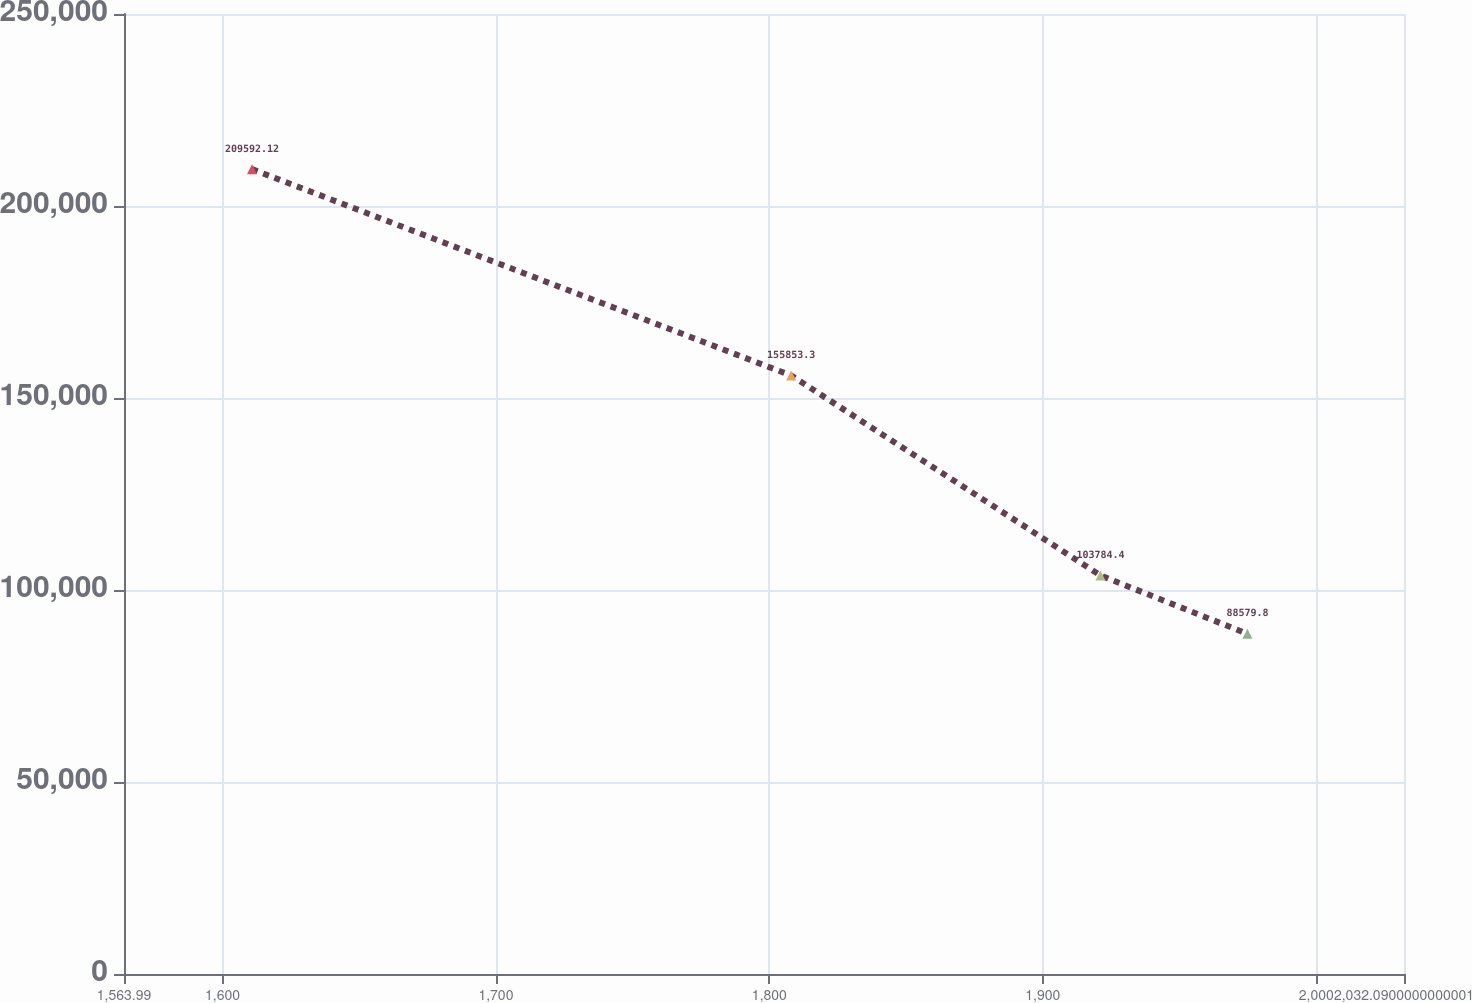Convert chart. <chart><loc_0><loc_0><loc_500><loc_500><line_chart><ecel><fcel>Unnamed: 1<nl><fcel>1610.8<fcel>209592<nl><fcel>1807.98<fcel>155853<nl><fcel>1921.1<fcel>103784<nl><fcel>1974.84<fcel>88579.8<nl><fcel>2078.9<fcel>57546.1<nl></chart> 